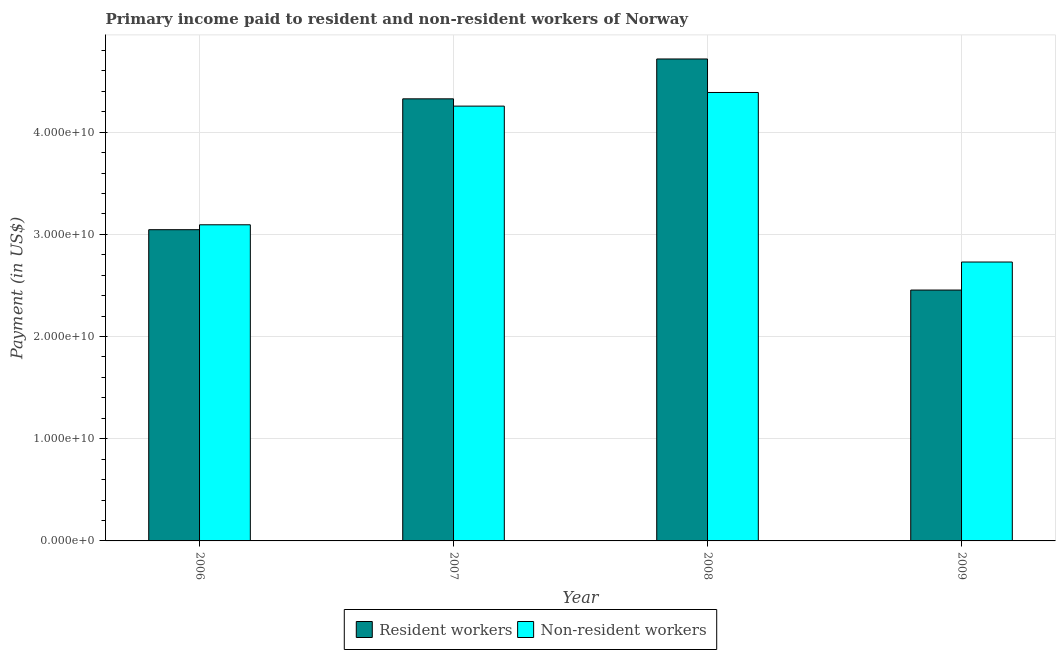How many different coloured bars are there?
Keep it short and to the point. 2. How many groups of bars are there?
Keep it short and to the point. 4. Are the number of bars on each tick of the X-axis equal?
Keep it short and to the point. Yes. How many bars are there on the 4th tick from the left?
Keep it short and to the point. 2. How many bars are there on the 4th tick from the right?
Offer a very short reply. 2. In how many cases, is the number of bars for a given year not equal to the number of legend labels?
Ensure brevity in your answer.  0. What is the payment made to non-resident workers in 2007?
Keep it short and to the point. 4.25e+1. Across all years, what is the maximum payment made to resident workers?
Ensure brevity in your answer.  4.72e+1. Across all years, what is the minimum payment made to resident workers?
Provide a short and direct response. 2.45e+1. What is the total payment made to resident workers in the graph?
Keep it short and to the point. 1.45e+11. What is the difference between the payment made to non-resident workers in 2006 and that in 2009?
Your answer should be very brief. 3.64e+09. What is the difference between the payment made to non-resident workers in 2006 and the payment made to resident workers in 2009?
Provide a succinct answer. 3.64e+09. What is the average payment made to non-resident workers per year?
Offer a very short reply. 3.62e+1. In the year 2006, what is the difference between the payment made to non-resident workers and payment made to resident workers?
Give a very brief answer. 0. What is the ratio of the payment made to resident workers in 2007 to that in 2009?
Ensure brevity in your answer.  1.76. Is the payment made to resident workers in 2006 less than that in 2008?
Make the answer very short. Yes. What is the difference between the highest and the second highest payment made to non-resident workers?
Ensure brevity in your answer.  1.33e+09. What is the difference between the highest and the lowest payment made to non-resident workers?
Ensure brevity in your answer.  1.66e+1. In how many years, is the payment made to non-resident workers greater than the average payment made to non-resident workers taken over all years?
Offer a very short reply. 2. What does the 2nd bar from the left in 2009 represents?
Ensure brevity in your answer.  Non-resident workers. What does the 1st bar from the right in 2009 represents?
Make the answer very short. Non-resident workers. How many bars are there?
Your response must be concise. 8. Are all the bars in the graph horizontal?
Provide a succinct answer. No. How many years are there in the graph?
Offer a terse response. 4. Does the graph contain any zero values?
Your answer should be very brief. No. Does the graph contain grids?
Your answer should be compact. Yes. Where does the legend appear in the graph?
Provide a succinct answer. Bottom center. How many legend labels are there?
Your answer should be compact. 2. How are the legend labels stacked?
Your response must be concise. Horizontal. What is the title of the graph?
Provide a succinct answer. Primary income paid to resident and non-resident workers of Norway. Does "Stunting" appear as one of the legend labels in the graph?
Your answer should be very brief. No. What is the label or title of the Y-axis?
Give a very brief answer. Payment (in US$). What is the Payment (in US$) of Resident workers in 2006?
Make the answer very short. 3.05e+1. What is the Payment (in US$) in Non-resident workers in 2006?
Provide a short and direct response. 3.09e+1. What is the Payment (in US$) of Resident workers in 2007?
Offer a very short reply. 4.33e+1. What is the Payment (in US$) of Non-resident workers in 2007?
Offer a very short reply. 4.25e+1. What is the Payment (in US$) of Resident workers in 2008?
Your answer should be compact. 4.72e+1. What is the Payment (in US$) of Non-resident workers in 2008?
Your answer should be compact. 4.39e+1. What is the Payment (in US$) in Resident workers in 2009?
Provide a short and direct response. 2.45e+1. What is the Payment (in US$) of Non-resident workers in 2009?
Keep it short and to the point. 2.73e+1. Across all years, what is the maximum Payment (in US$) of Resident workers?
Give a very brief answer. 4.72e+1. Across all years, what is the maximum Payment (in US$) of Non-resident workers?
Provide a short and direct response. 4.39e+1. Across all years, what is the minimum Payment (in US$) of Resident workers?
Your answer should be compact. 2.45e+1. Across all years, what is the minimum Payment (in US$) of Non-resident workers?
Your answer should be very brief. 2.73e+1. What is the total Payment (in US$) of Resident workers in the graph?
Give a very brief answer. 1.45e+11. What is the total Payment (in US$) of Non-resident workers in the graph?
Your response must be concise. 1.45e+11. What is the difference between the Payment (in US$) in Resident workers in 2006 and that in 2007?
Give a very brief answer. -1.28e+1. What is the difference between the Payment (in US$) of Non-resident workers in 2006 and that in 2007?
Give a very brief answer. -1.16e+1. What is the difference between the Payment (in US$) of Resident workers in 2006 and that in 2008?
Ensure brevity in your answer.  -1.67e+1. What is the difference between the Payment (in US$) of Non-resident workers in 2006 and that in 2008?
Provide a succinct answer. -1.29e+1. What is the difference between the Payment (in US$) in Resident workers in 2006 and that in 2009?
Provide a succinct answer. 5.91e+09. What is the difference between the Payment (in US$) in Non-resident workers in 2006 and that in 2009?
Offer a terse response. 3.64e+09. What is the difference between the Payment (in US$) in Resident workers in 2007 and that in 2008?
Make the answer very short. -3.90e+09. What is the difference between the Payment (in US$) of Non-resident workers in 2007 and that in 2008?
Provide a short and direct response. -1.33e+09. What is the difference between the Payment (in US$) of Resident workers in 2007 and that in 2009?
Give a very brief answer. 1.87e+1. What is the difference between the Payment (in US$) in Non-resident workers in 2007 and that in 2009?
Provide a short and direct response. 1.53e+1. What is the difference between the Payment (in US$) in Resident workers in 2008 and that in 2009?
Make the answer very short. 2.26e+1. What is the difference between the Payment (in US$) of Non-resident workers in 2008 and that in 2009?
Keep it short and to the point. 1.66e+1. What is the difference between the Payment (in US$) in Resident workers in 2006 and the Payment (in US$) in Non-resident workers in 2007?
Your answer should be very brief. -1.21e+1. What is the difference between the Payment (in US$) in Resident workers in 2006 and the Payment (in US$) in Non-resident workers in 2008?
Your answer should be compact. -1.34e+1. What is the difference between the Payment (in US$) in Resident workers in 2006 and the Payment (in US$) in Non-resident workers in 2009?
Provide a short and direct response. 3.16e+09. What is the difference between the Payment (in US$) of Resident workers in 2007 and the Payment (in US$) of Non-resident workers in 2008?
Offer a very short reply. -6.23e+08. What is the difference between the Payment (in US$) in Resident workers in 2007 and the Payment (in US$) in Non-resident workers in 2009?
Make the answer very short. 1.60e+1. What is the difference between the Payment (in US$) of Resident workers in 2008 and the Payment (in US$) of Non-resident workers in 2009?
Ensure brevity in your answer.  1.99e+1. What is the average Payment (in US$) in Resident workers per year?
Give a very brief answer. 3.64e+1. What is the average Payment (in US$) in Non-resident workers per year?
Keep it short and to the point. 3.62e+1. In the year 2006, what is the difference between the Payment (in US$) in Resident workers and Payment (in US$) in Non-resident workers?
Keep it short and to the point. -4.80e+08. In the year 2007, what is the difference between the Payment (in US$) in Resident workers and Payment (in US$) in Non-resident workers?
Give a very brief answer. 7.12e+08. In the year 2008, what is the difference between the Payment (in US$) in Resident workers and Payment (in US$) in Non-resident workers?
Keep it short and to the point. 3.28e+09. In the year 2009, what is the difference between the Payment (in US$) in Resident workers and Payment (in US$) in Non-resident workers?
Give a very brief answer. -2.74e+09. What is the ratio of the Payment (in US$) of Resident workers in 2006 to that in 2007?
Keep it short and to the point. 0.7. What is the ratio of the Payment (in US$) in Non-resident workers in 2006 to that in 2007?
Make the answer very short. 0.73. What is the ratio of the Payment (in US$) in Resident workers in 2006 to that in 2008?
Your answer should be very brief. 0.65. What is the ratio of the Payment (in US$) of Non-resident workers in 2006 to that in 2008?
Give a very brief answer. 0.7. What is the ratio of the Payment (in US$) of Resident workers in 2006 to that in 2009?
Your response must be concise. 1.24. What is the ratio of the Payment (in US$) in Non-resident workers in 2006 to that in 2009?
Your response must be concise. 1.13. What is the ratio of the Payment (in US$) of Resident workers in 2007 to that in 2008?
Keep it short and to the point. 0.92. What is the ratio of the Payment (in US$) of Non-resident workers in 2007 to that in 2008?
Offer a terse response. 0.97. What is the ratio of the Payment (in US$) of Resident workers in 2007 to that in 2009?
Your response must be concise. 1.76. What is the ratio of the Payment (in US$) of Non-resident workers in 2007 to that in 2009?
Offer a terse response. 1.56. What is the ratio of the Payment (in US$) in Resident workers in 2008 to that in 2009?
Offer a very short reply. 1.92. What is the ratio of the Payment (in US$) of Non-resident workers in 2008 to that in 2009?
Provide a succinct answer. 1.61. What is the difference between the highest and the second highest Payment (in US$) of Resident workers?
Offer a very short reply. 3.90e+09. What is the difference between the highest and the second highest Payment (in US$) in Non-resident workers?
Your answer should be compact. 1.33e+09. What is the difference between the highest and the lowest Payment (in US$) in Resident workers?
Your answer should be very brief. 2.26e+1. What is the difference between the highest and the lowest Payment (in US$) of Non-resident workers?
Your response must be concise. 1.66e+1. 